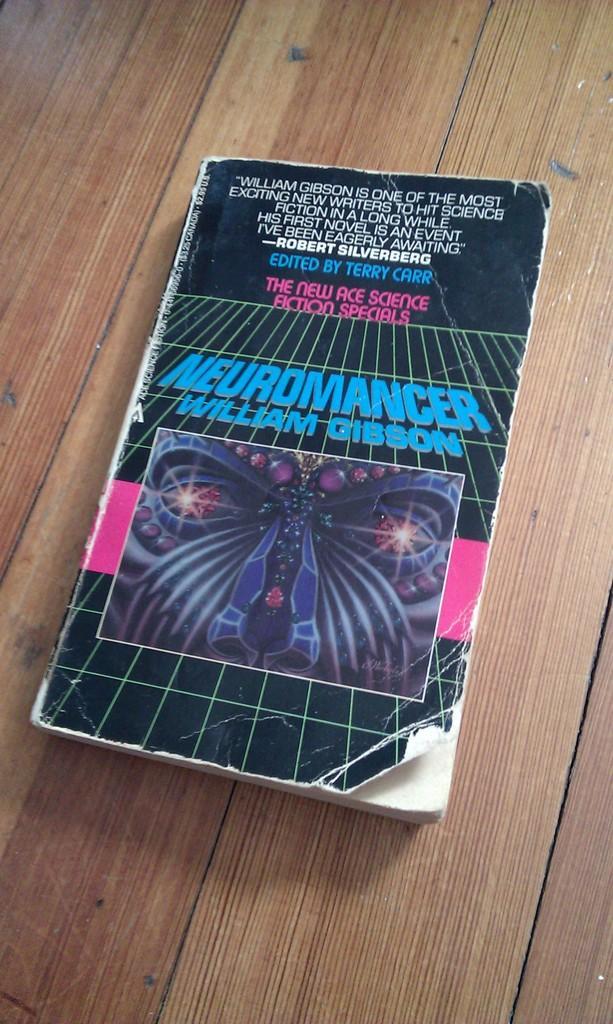Please provide a concise description of this image. In this image we can see a book on a wooden platform. On the book we can see a picture and text written on it. 